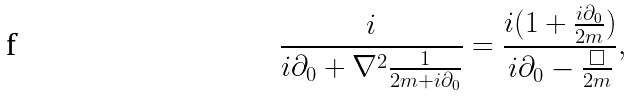Convert formula to latex. <formula><loc_0><loc_0><loc_500><loc_500>\frac { i } { i \partial _ { 0 } + \nabla ^ { 2 } \frac { 1 } { 2 m + i \partial _ { 0 } } } = \frac { i ( 1 + \frac { i \partial _ { 0 } } { 2 m } ) } { i \partial _ { 0 } - \frac { \Box } { 2 m } } ,</formula> 